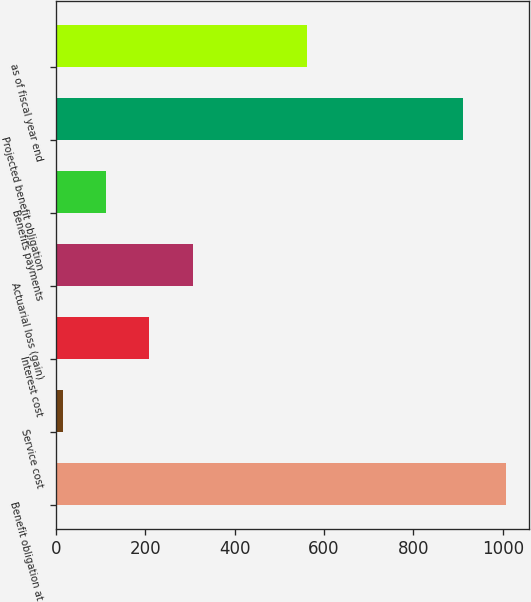<chart> <loc_0><loc_0><loc_500><loc_500><bar_chart><fcel>Benefit obligation at<fcel>Service cost<fcel>Interest cost<fcel>Actuarial loss (gain)<fcel>Benefits payments<fcel>Projected benefit obligation<fcel>as of fiscal year end<nl><fcel>1007.75<fcel>16.4<fcel>209.3<fcel>305.75<fcel>112.85<fcel>911.3<fcel>561.7<nl></chart> 